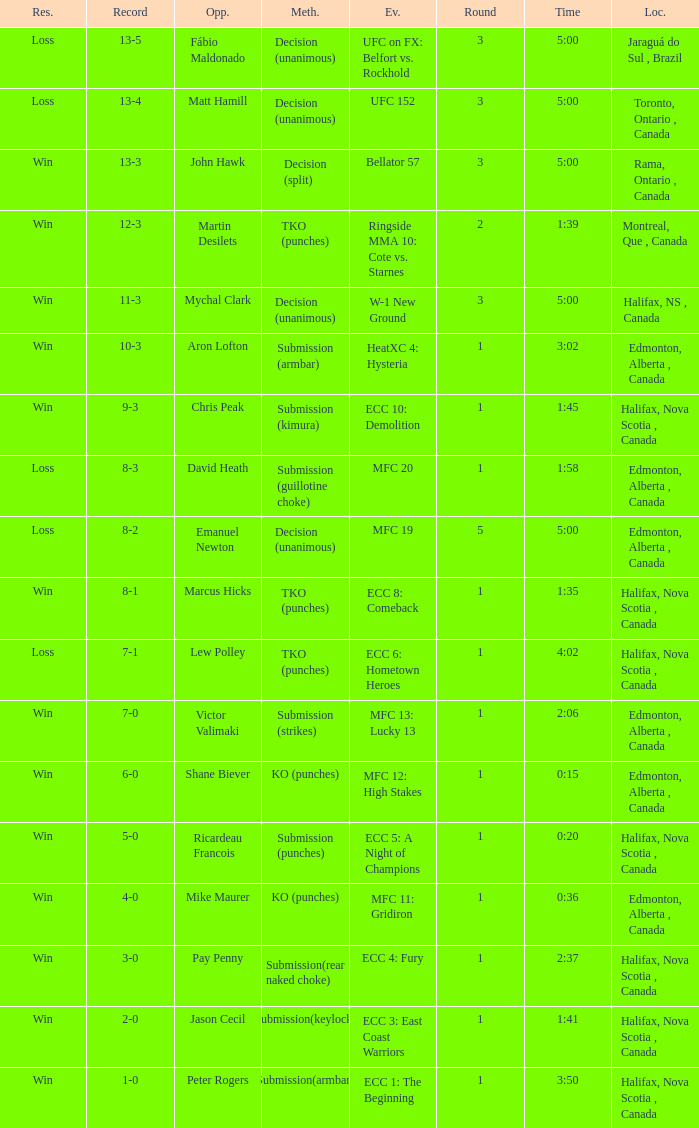What is the round of the match with Emanuel Newton as the opponent? 5.0. 